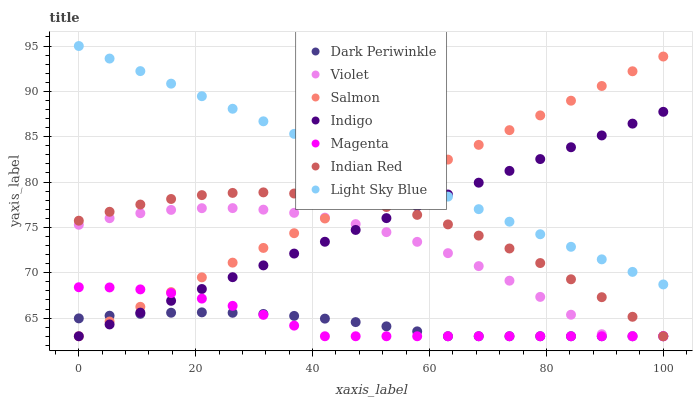Does Dark Periwinkle have the minimum area under the curve?
Answer yes or no. Yes. Does Light Sky Blue have the maximum area under the curve?
Answer yes or no. Yes. Does Salmon have the minimum area under the curve?
Answer yes or no. No. Does Salmon have the maximum area under the curve?
Answer yes or no. No. Is Light Sky Blue the smoothest?
Answer yes or no. Yes. Is Violet the roughest?
Answer yes or no. Yes. Is Salmon the smoothest?
Answer yes or no. No. Is Salmon the roughest?
Answer yes or no. No. Does Indigo have the lowest value?
Answer yes or no. Yes. Does Light Sky Blue have the lowest value?
Answer yes or no. No. Does Light Sky Blue have the highest value?
Answer yes or no. Yes. Does Salmon have the highest value?
Answer yes or no. No. Is Magenta less than Light Sky Blue?
Answer yes or no. Yes. Is Light Sky Blue greater than Magenta?
Answer yes or no. Yes. Does Magenta intersect Dark Periwinkle?
Answer yes or no. Yes. Is Magenta less than Dark Periwinkle?
Answer yes or no. No. Is Magenta greater than Dark Periwinkle?
Answer yes or no. No. Does Magenta intersect Light Sky Blue?
Answer yes or no. No. 